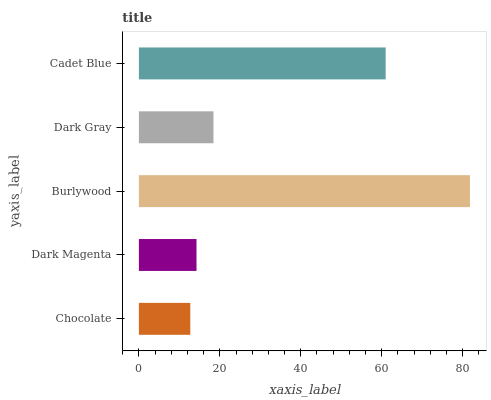Is Chocolate the minimum?
Answer yes or no. Yes. Is Burlywood the maximum?
Answer yes or no. Yes. Is Dark Magenta the minimum?
Answer yes or no. No. Is Dark Magenta the maximum?
Answer yes or no. No. Is Dark Magenta greater than Chocolate?
Answer yes or no. Yes. Is Chocolate less than Dark Magenta?
Answer yes or no. Yes. Is Chocolate greater than Dark Magenta?
Answer yes or no. No. Is Dark Magenta less than Chocolate?
Answer yes or no. No. Is Dark Gray the high median?
Answer yes or no. Yes. Is Dark Gray the low median?
Answer yes or no. Yes. Is Chocolate the high median?
Answer yes or no. No. Is Burlywood the low median?
Answer yes or no. No. 